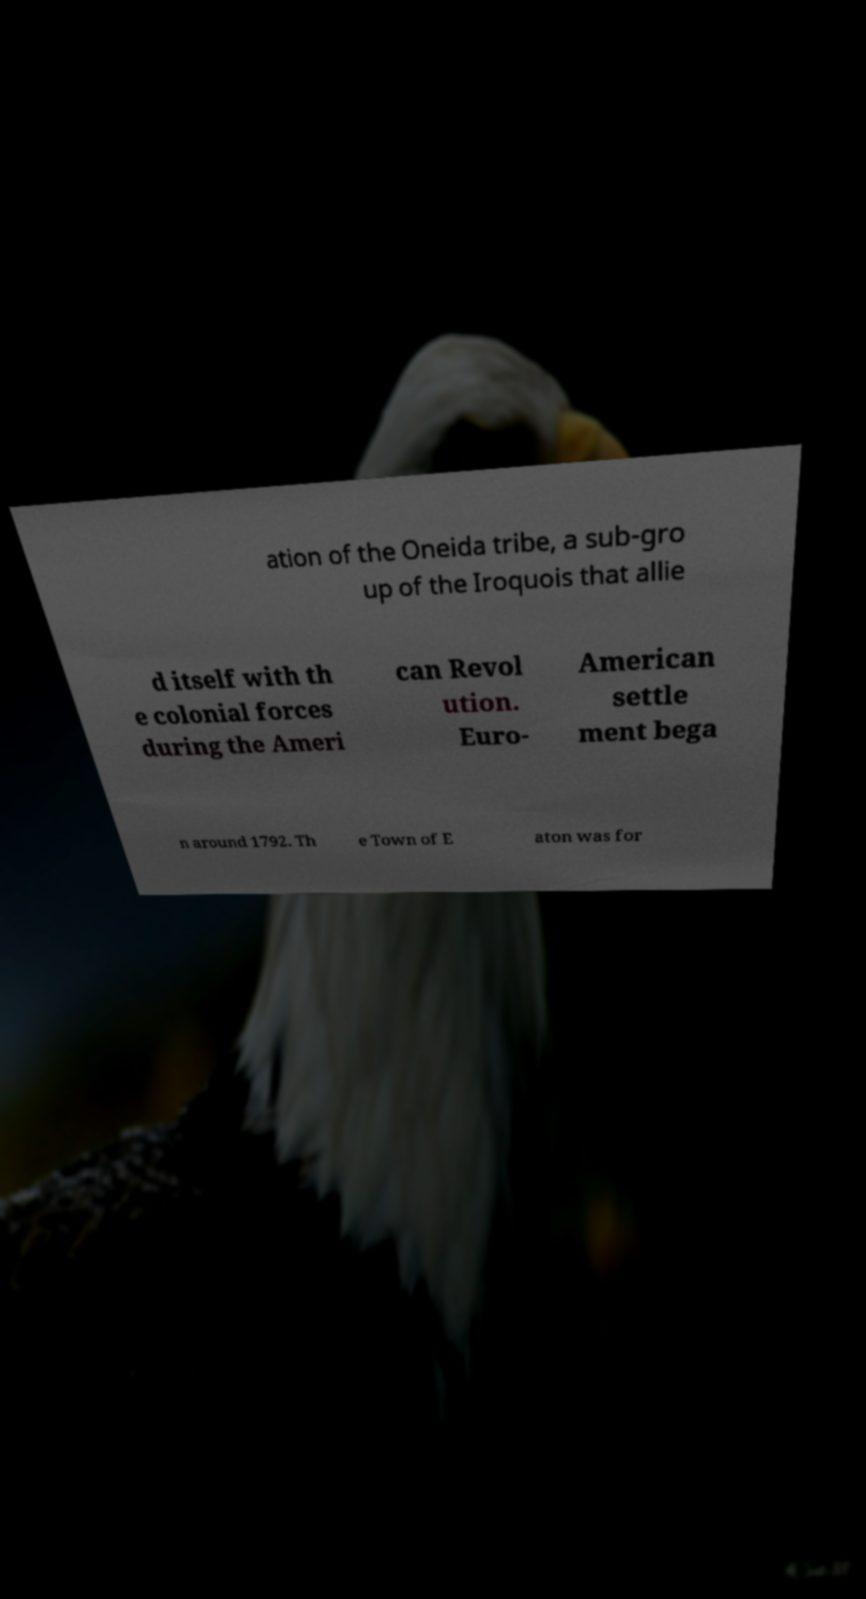Could you extract and type out the text from this image? ation of the Oneida tribe, a sub-gro up of the Iroquois that allie d itself with th e colonial forces during the Ameri can Revol ution. Euro- American settle ment bega n around 1792. Th e Town of E aton was for 